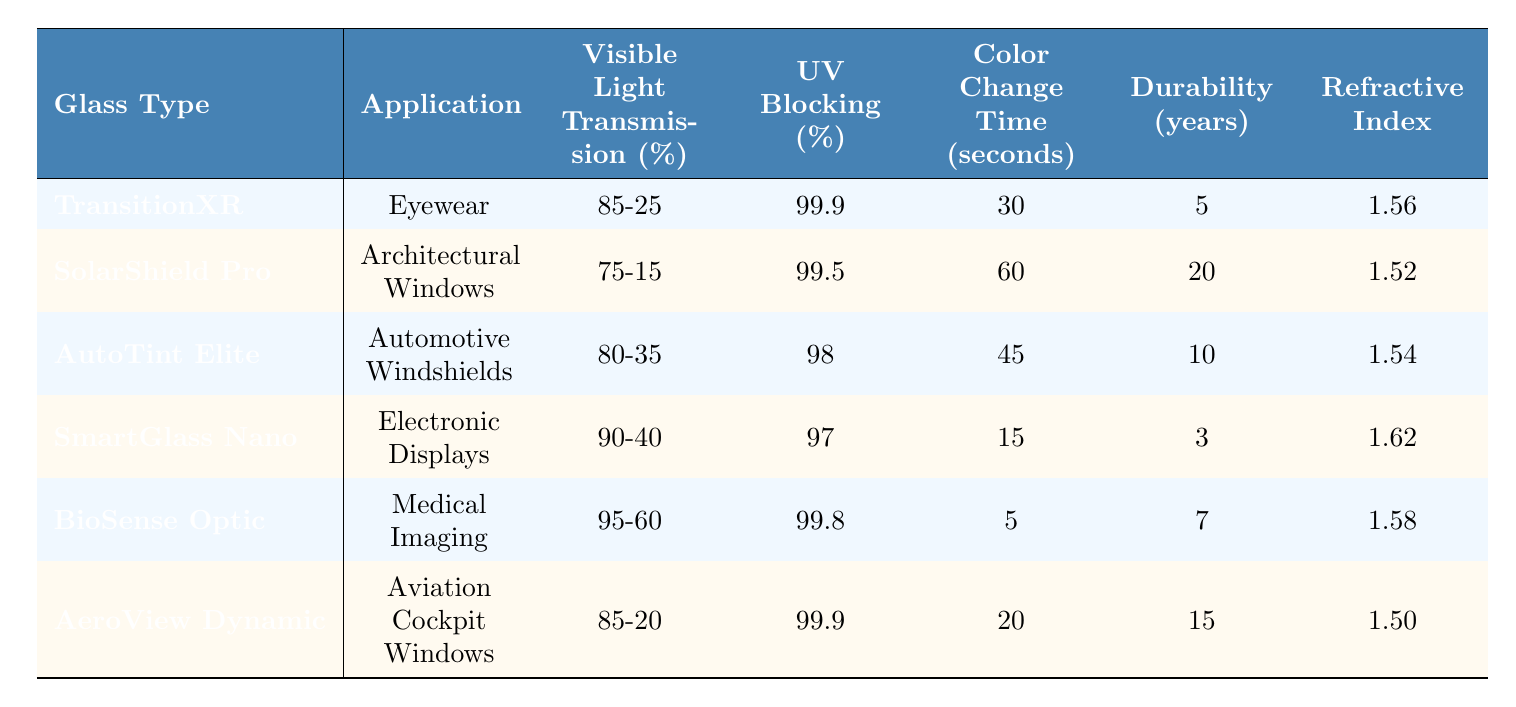What is the visible light transmission percentage range for BioSense Optic? The table shows that the visible light transmission percentage for BioSense Optic is between 95-60%. Therefore, its range is directly stated in the table.
Answer: 95-60% How many years of durability does AutoTint Elite have? According to the table, AutoTint Elite has a durability of 10 years, as specified in the respective row for this glass type.
Answer: 10 years Which glass type has the longest color change time? Review the "Color Change Time (seconds)" column; SolarShield Pro has the longest time at 60 seconds, which is greater than all other listed types.
Answer: SolarShield Pro What is the average refractive index of all glass types listed? First, sum the refractive indexes: 1.56 + 1.52 + 1.54 + 1.62 + 1.58 + 1.50 = 9.32. Then divide by the number of glass types (6), giving 9.32 / 6 = 1.553.
Answer: 1.553 Does SmartGlass Nano have a higher UV blocking percentage than TransitionXR? Check the UV blocking percentages: SmartGlass Nano (97%) vs. TransitionXR (99.9%). Since 97% is less than 99.9%, the statement is false.
Answer: No Which application has the highest visible light transmission percentage? Investigating the "Visible Light Transmission (%)" column shows BioSense Optic has the highest starting value of 95%. Therefore, it has the highest percentage for its application.
Answer: Medical Imaging Is it true that all glass types block more than 95% of UV radiation? Check the "UV Blocking (%)" for all types: the lowest value is 97% for SmartGlass Nano. Since all types exceed 95%, the statement is true.
Answer: Yes What is the difference in color change time between SolarShield Pro and AutoTint Elite? SolarShield Pro's color change time is 60 seconds, and AutoTint Elite's is 45 seconds, so the difference is 60 - 45 = 15 seconds.
Answer: 15 seconds Which glass type has the lowest durability? Looking at the "Durability (years)" column, SmartGlass Nano has the lowest value at 3 years, which is less than others.
Answer: SmartGlass Nano Is there a glass type that has a combination of high durability and low color change time? Compare the columns; SolarShield Pro has high durability (20 years) with a higher color change time (60 seconds). No combination fits the criteria perfectly, indicating that they are inversely related in the table.
Answer: No 